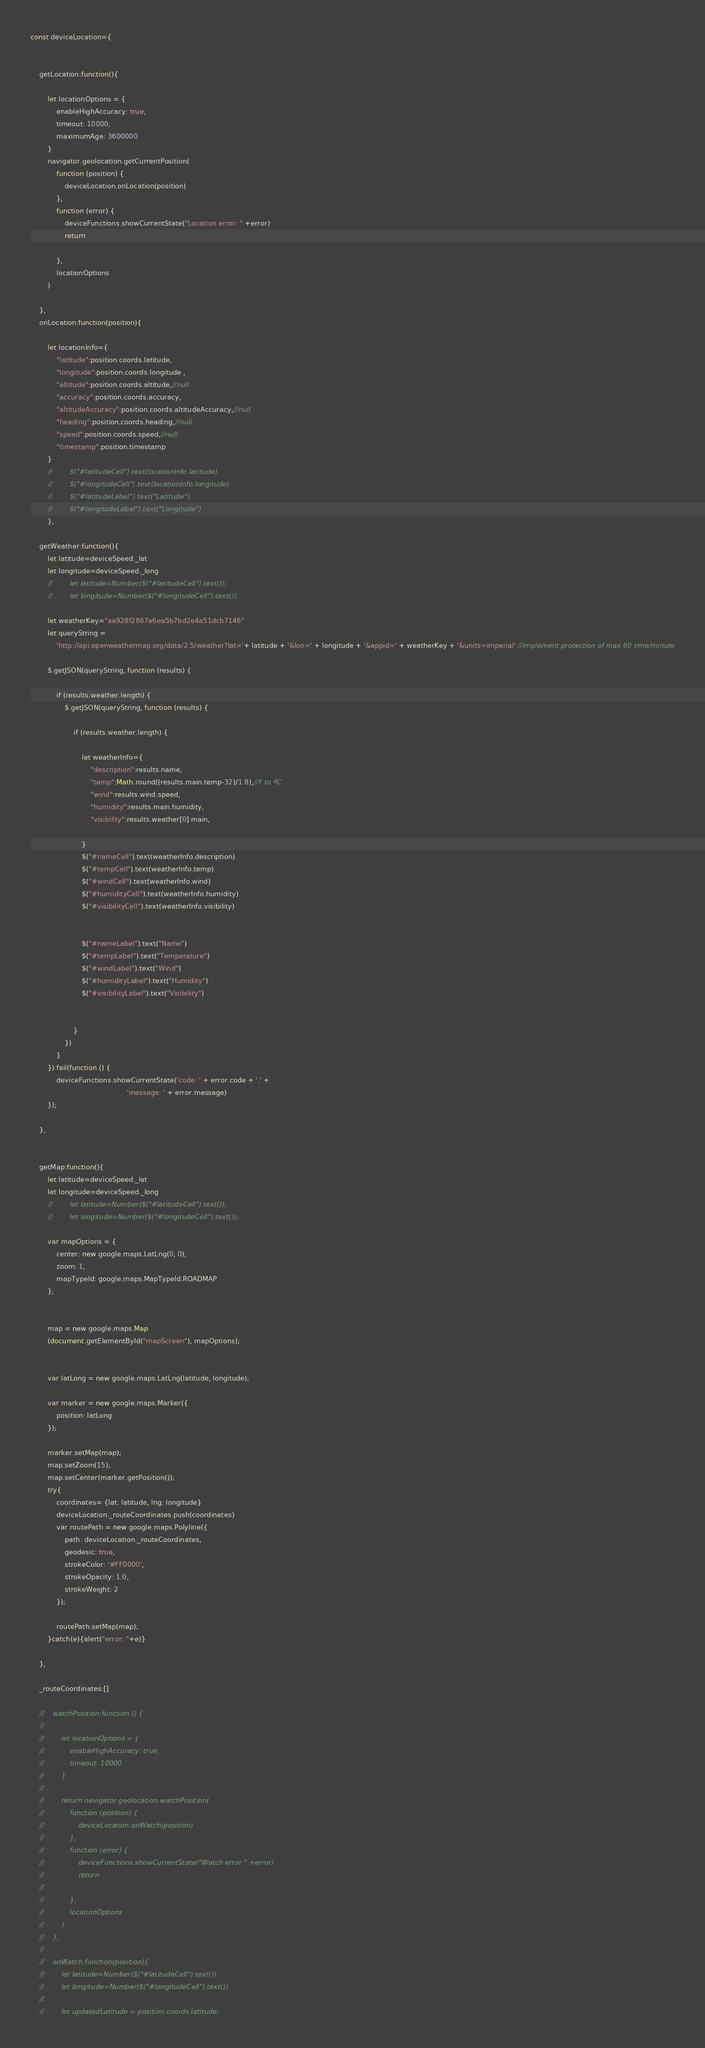Convert code to text. <code><loc_0><loc_0><loc_500><loc_500><_JavaScript_>
const deviceLocation={


    getLocation:function(){

        let locationOptions = {
            enableHighAccuracy: true,
            timeout: 10000,
            maximumAge: 3600000
        }
        navigator.geolocation.getCurrentPosition(
            function (position) {
                deviceLocation.onLocation(position)
            },
            function (error) {
                deviceFunctions.showCurrentState("Location error: " +error)
                return

            },
            locationOptions
        )

    },
    onLocation:function(position){

        let locationInfo={
            "latitude":position.coords.latitude,
            "longitude":position.coords.longitude ,
            "altitude":position.coords.altitude,//null
            "accuracy":position.coords.accuracy,
            "altitudeAccuracy":position.coords.altitudeAccuracy,//null
            "heading":position.coords.heading,//null
            "speed":position.coords.speed,//null
            "timestamp":position.timestamp
        }
        //        $("#latitudeCell").text(locationInfo.latitude)
        //        $("#longitudeCell").text(locationInfo.longitude)
        //        $("#latitudeLabel").text("Latitude")
        //        $("#longitudeLabel").text("Longitude")
        },

    getWeather:function(){
        let latitude=deviceSpeed._lat
        let longitude=deviceSpeed._long
        //        let latitude=Number($("#latitudeCell").text());
        //        let longitude=Number($("#longitudeCell").text());

        let weatherKey="aa928f2867a6ea5b7bd2e4a51dcb7146"
        let queryString =
            'http://api.openweathermap.org/data/2.5/weather?lat='+ latitude + '&lon=' + longitude + '&appid=' + weatherKey + '&units=imperial' //implement protection of max 60 time/minute

        $.getJSON(queryString, function (results) {

            if (results.weather.length) {
                $.getJSON(queryString, function (results) {

                    if (results.weather.length) {

                        let weatherInfo={
                            "description":results.name,
                            "temp":Math.round((results.main.temp-32)/1.8),//F to ºC
                            "wind":results.wind.speed,
                            "humidity":results.main.humidity,
                            "visibility":results.weather[0].main,

                        }
                        $("#nameCell").text(weatherInfo.description)
                        $("#tempCell").text(weatherInfo.temp)
                        $("#windCell").text(weatherInfo.wind)
                        $("#humidityCell").text(weatherInfo.humidity)
                        $("#visibilityCell").text(weatherInfo.visibility)


                        $("#nameLabel").text("Name")
                        $("#tempLabel").text("Temperature")
                        $("#windLabel").text("Wind")
                        $("#humidityLabel").text("Humidity")
                        $("#visibilityLabel").text("Visibility")


                    }
                })
            }
        }).fail(function () {
            deviceFunctions.showCurrentState('code: ' + error.code + ',' +
                                             'message: ' + error.message)
        });   

    },


    getMap:function(){
        let latitude=deviceSpeed._lat
        let longitude=deviceSpeed._long
        //        let latitude=Number($("#latitudeCell").text());
        //        let longitude=Number($("#longitudeCell").text());

        var mapOptions = {
            center: new google.maps.LatLng(0, 0),
            zoom: 1,
            mapTypeId: google.maps.MapTypeId.ROADMAP
        };


        map = new google.maps.Map
        (document.getElementById("mapScreen"), mapOptions);


        var latLong = new google.maps.LatLng(latitude, longitude);

        var marker = new google.maps.Marker({
            position: latLong
        });

        marker.setMap(map);
        map.setZoom(15);
        map.setCenter(marker.getPosition());
        try{
            coordinates= {lat: latitude, lng: longitude}
            deviceLocation._routeCoordinates.push(coordinates)
            var routePath = new google.maps.Polyline({
                path: deviceLocation._routeCoordinates,
                geodesic: true,
                strokeColor: '#FF0000',
                strokeOpacity: 1.0,
                strokeWeight: 2
            });

            routePath.setMap(map);
        }catch(e){alert("error: "+e)}

    },

    _routeCoordinates:[]

    //    watchPosition:function () {
    //
    //        let locationOptions = {
    //            enableHighAccuracy: true,
    //            timeout: 10000
    //        }
    //
    //        return navigator.geolocation.watchPosition(
    //            function (position) {
    //                deviceLocation.onWatch(position)
    //            },
    //            function (error) {
    //                deviceFunctions.showCurrentState("Watch error:" +error)
    //                return
    //
    //            },
    //            locationOptions
    //        )
    //    },
    //
    //    onWatch:function(position){
    //        let latitude=Number($("#latitudeCell").text())
    //        let longitude=Number($("#longitudeCell").text())
    //
    //        let updatedLatitude = position.coords.latitude;</code> 